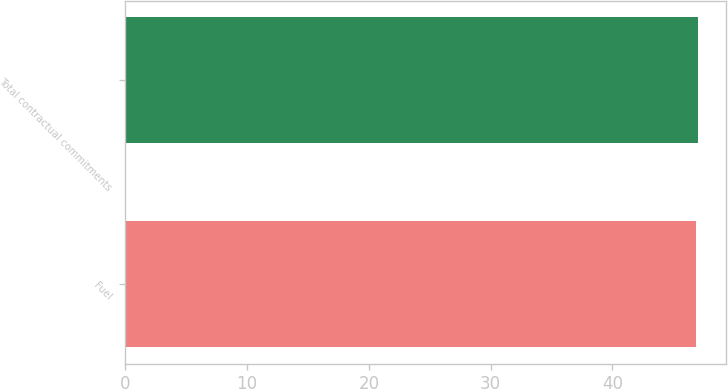Convert chart to OTSL. <chart><loc_0><loc_0><loc_500><loc_500><bar_chart><fcel>Fuel<fcel>Total contractual commitments<nl><fcel>46.9<fcel>47<nl></chart> 